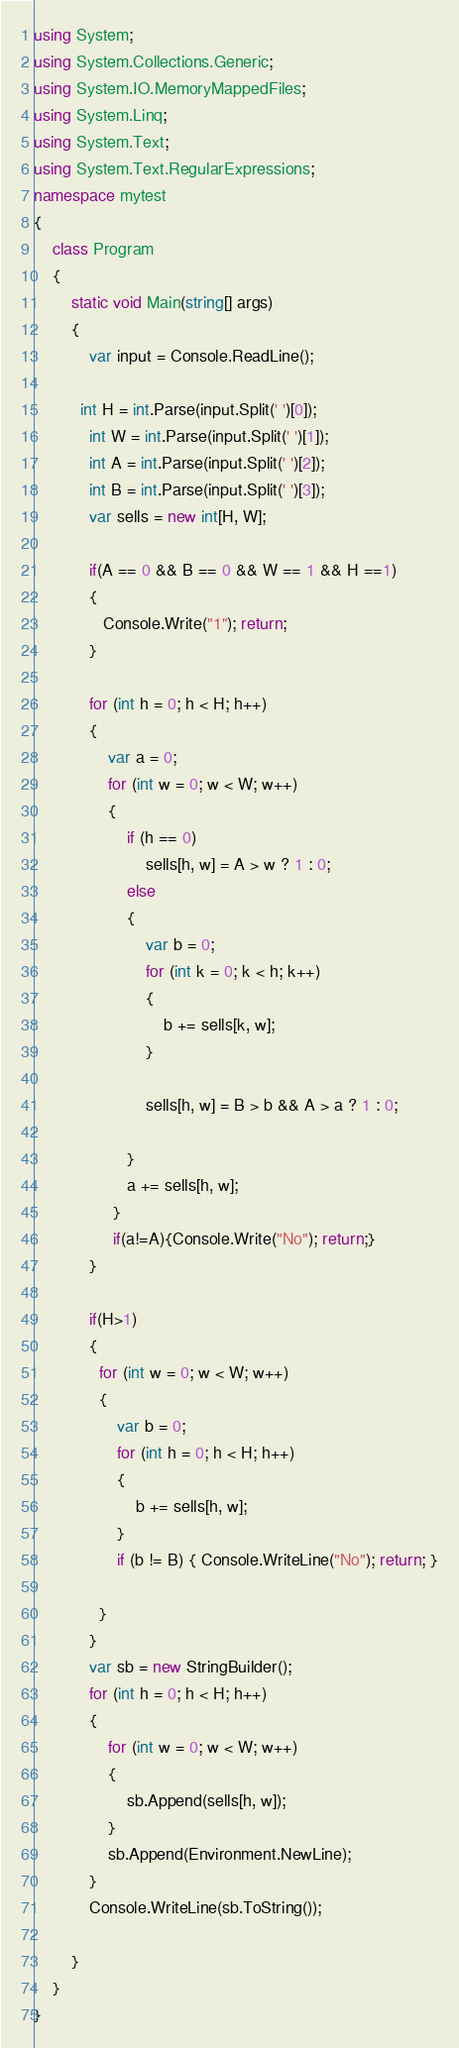Convert code to text. <code><loc_0><loc_0><loc_500><loc_500><_C#_>using System;
using System.Collections.Generic;
using System.IO.MemoryMappedFiles;
using System.Linq;
using System.Text;
using System.Text.RegularExpressions;
namespace mytest
{
    class Program
    {
        static void Main(string[] args)
        {
            var input = Console.ReadLine();
            
          int H = int.Parse(input.Split(' ')[0]);
            int W = int.Parse(input.Split(' ')[1]);
            int A = int.Parse(input.Split(' ')[2]);
            int B = int.Parse(input.Split(' ')[3]);
            var sells = new int[H, W];

            if(A == 0 && B == 0 && W == 1 && H ==1)
            {
               Console.Write("1"); return;
            }
          
            for (int h = 0; h < H; h++)
            {
                var a = 0;
                for (int w = 0; w < W; w++)
                {
                    if (h == 0)
                        sells[h, w] = A > w ? 1 : 0;
                    else
                    {
                        var b = 0;
                        for (int k = 0; k < h; k++)
                        {
                            b += sells[k, w];
                        }

                        sells[h, w] = B > b && A > a ? 1 : 0;

                    }
                    a += sells[h, w];
                 }
                 if(a!=A){Console.Write("No"); return;}
            }

            if(H>1)
            {
              for (int w = 0; w < W; w++)
              {
                  var b = 0;
                  for (int h = 0; h < H; h++)
                  {
                      b += sells[h, w];
                  }
                  if (b != B) { Console.WriteLine("No"); return; }

              }
            }
            var sb = new StringBuilder();
            for (int h = 0; h < H; h++)
            {
                for (int w = 0; w < W; w++)
                {
                    sb.Append(sells[h, w]);
                }
                sb.Append(Environment.NewLine);
            }
            Console.WriteLine(sb.ToString());

        }
    }
}
</code> 